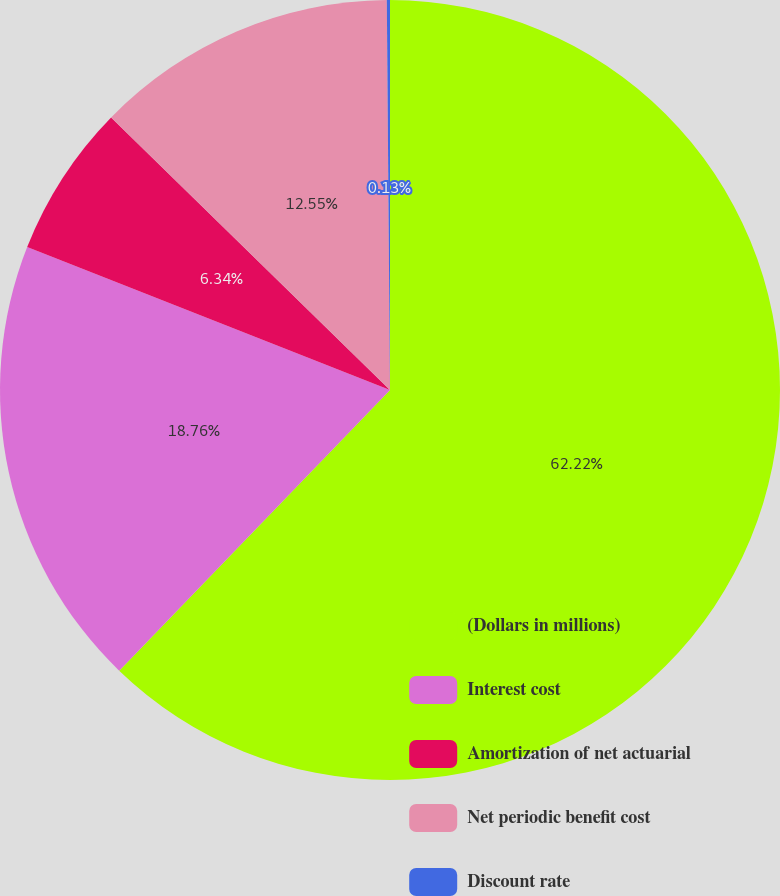Convert chart to OTSL. <chart><loc_0><loc_0><loc_500><loc_500><pie_chart><fcel>(Dollars in millions)<fcel>Interest cost<fcel>Amortization of net actuarial<fcel>Net periodic benefit cost<fcel>Discount rate<nl><fcel>62.21%<fcel>18.76%<fcel>6.34%<fcel>12.55%<fcel>0.13%<nl></chart> 